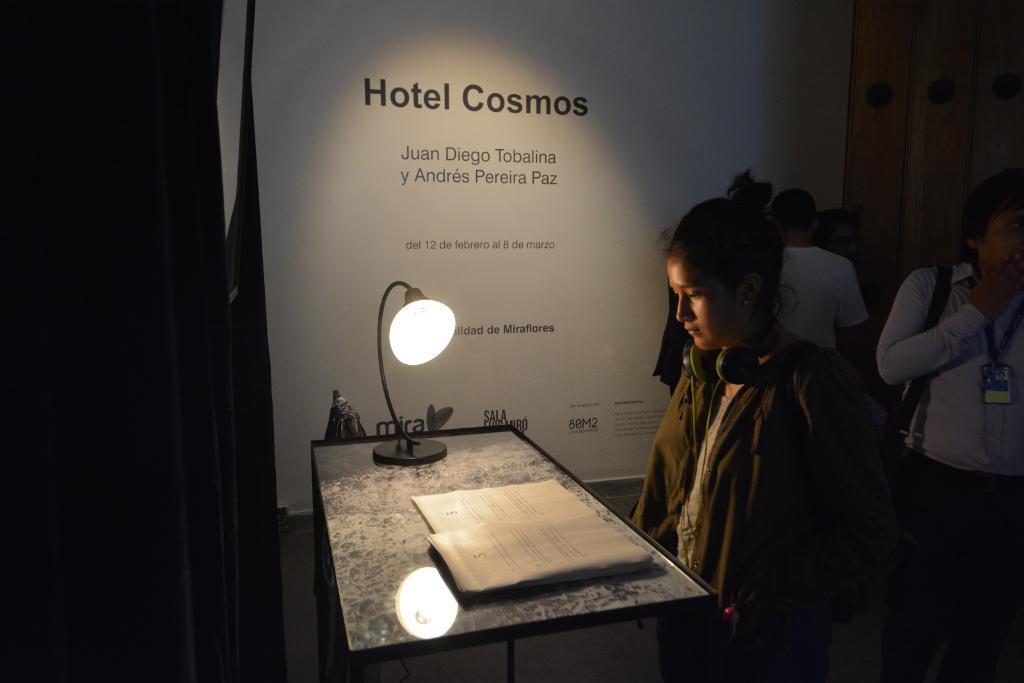Could you give a brief overview of what you see in this image? This is the woman standing. I can see a headset around her neck. This is the table with a study lamp and a book. I think this looks like a banner. I can see few people standing. This looks like a wooden board. 